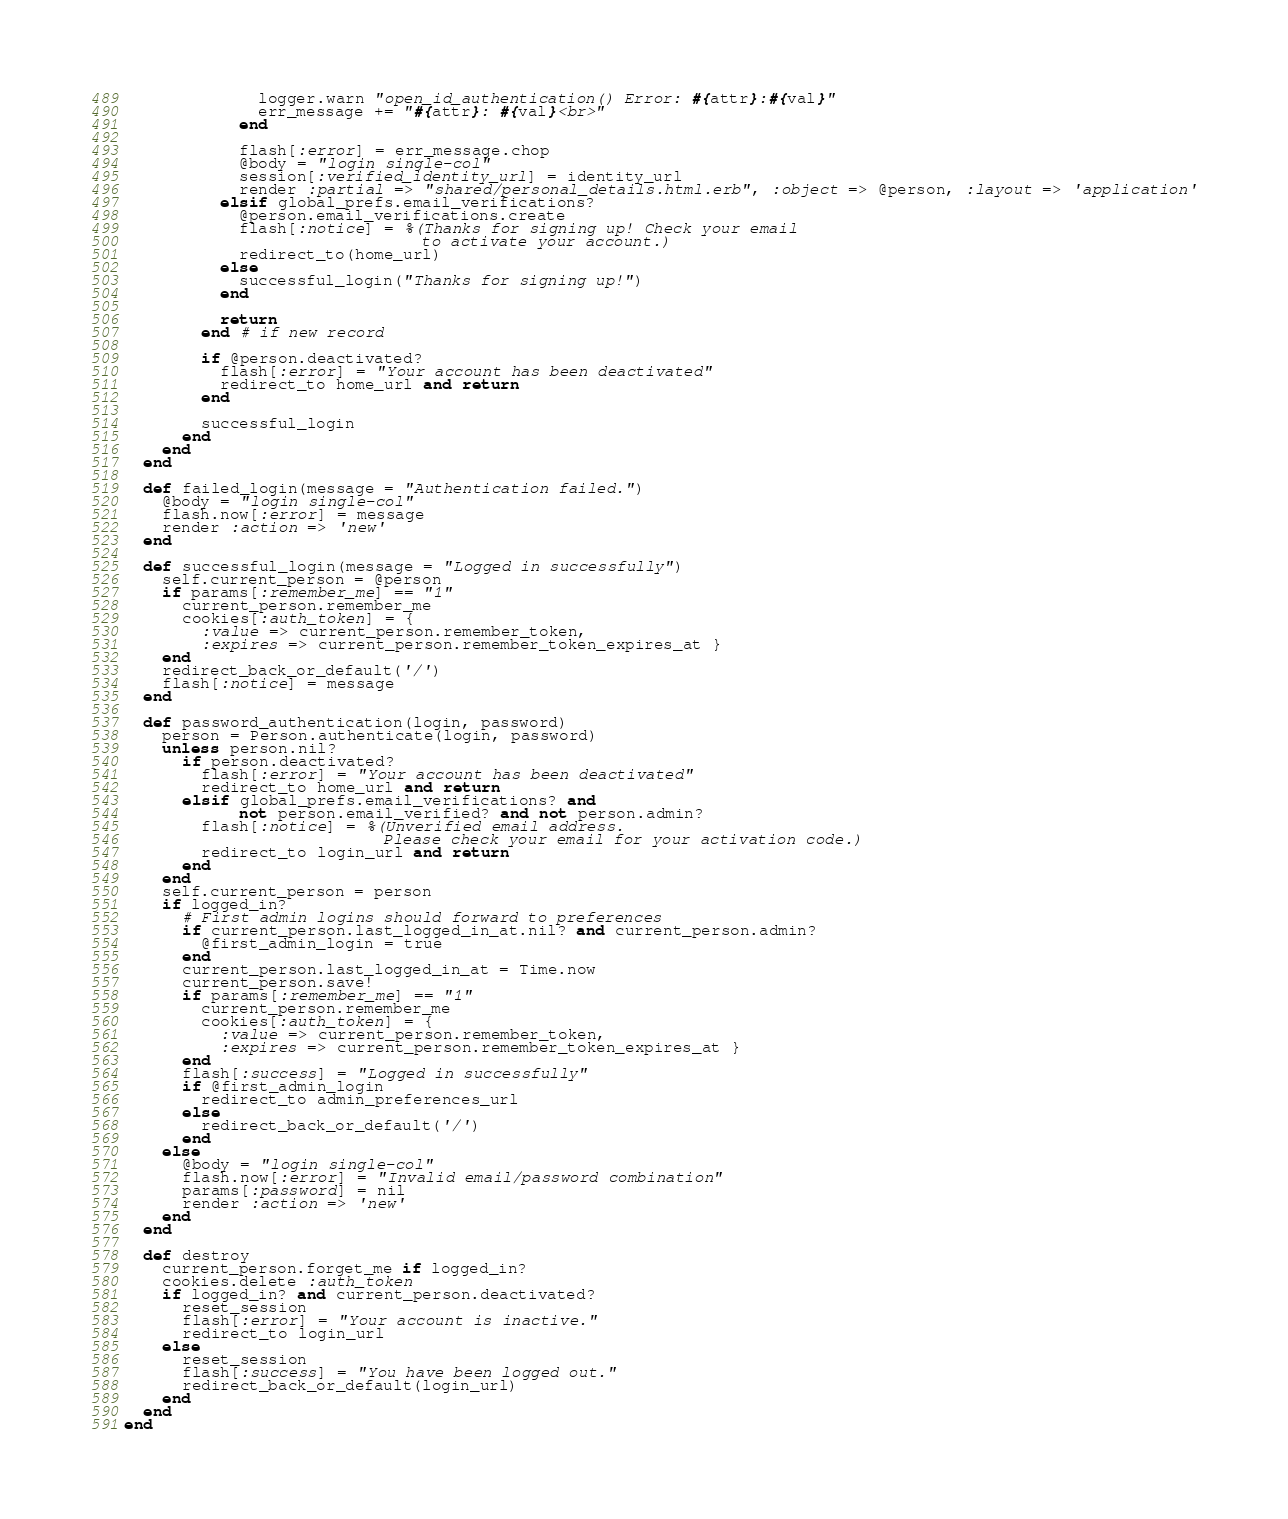<code> <loc_0><loc_0><loc_500><loc_500><_Ruby_>              logger.warn "open_id_authentication() Error: #{attr}:#{val}"
              err_message += "#{attr}: #{val}<br>"
            end
 
            flash[:error] = err_message.chop
            @body = "login single-col"
            session[:verified_identity_url] = identity_url
            render :partial => "shared/personal_details.html.erb", :object => @person, :layout => 'application'
          elsif global_prefs.email_verifications?
            @person.email_verifications.create
            flash[:notice] = %(Thanks for signing up! Check your email
                               to activate your account.)
            redirect_to(home_url)
          else
            successful_login("Thanks for signing up!")
          end

          return
        end # if new record

        if @person.deactivated?
          flash[:error] = "Your account has been deactivated"
          redirect_to home_url and return
        end

        successful_login
      end
    end
  end

  def failed_login(message = "Authentication failed.")
    @body = "login single-col"
    flash.now[:error] = message
    render :action => 'new'
  end
  
  def successful_login(message = "Logged in successfully")
    self.current_person = @person
    if params[:remember_me] == "1"
      current_person.remember_me
      cookies[:auth_token] = {
        :value => current_person.remember_token,
        :expires => current_person.remember_token_expires_at }
    end
    redirect_back_or_default('/')
    flash[:notice] = message
  end

  def password_authentication(login, password)
    person = Person.authenticate(login, password)
    unless person.nil?
      if person.deactivated?
        flash[:error] = "Your account has been deactivated"
        redirect_to home_url and return
      elsif global_prefs.email_verifications? and 
            not person.email_verified? and not person.admin?
        flash[:notice] = %(Unverified email address. 
                           Please check your email for your activation code.)
        redirect_to login_url and return
      end
    end
    self.current_person = person
    if logged_in?
      # First admin logins should forward to preferences
      if current_person.last_logged_in_at.nil? and current_person.admin?
        @first_admin_login = true
      end
      current_person.last_logged_in_at = Time.now
      current_person.save!
      if params[:remember_me] == "1"
        current_person.remember_me
        cookies[:auth_token] = {
          :value => current_person.remember_token,
          :expires => current_person.remember_token_expires_at }
      end
      flash[:success] = "Logged in successfully"
      if @first_admin_login
        redirect_to admin_preferences_url
      else
        redirect_back_or_default('/')
      end
    else
      @body = "login single-col"
      flash.now[:error] = "Invalid email/password combination"
      params[:password] = nil
      render :action => 'new'
    end
  end

  def destroy
    current_person.forget_me if logged_in?
    cookies.delete :auth_token
    if logged_in? and current_person.deactivated?
      reset_session
      flash[:error] = "Your account is inactive."
      redirect_to login_url
    else
      reset_session
      flash[:success] = "You have been logged out."
      redirect_back_or_default(login_url)
    end
  end
end
</code> 